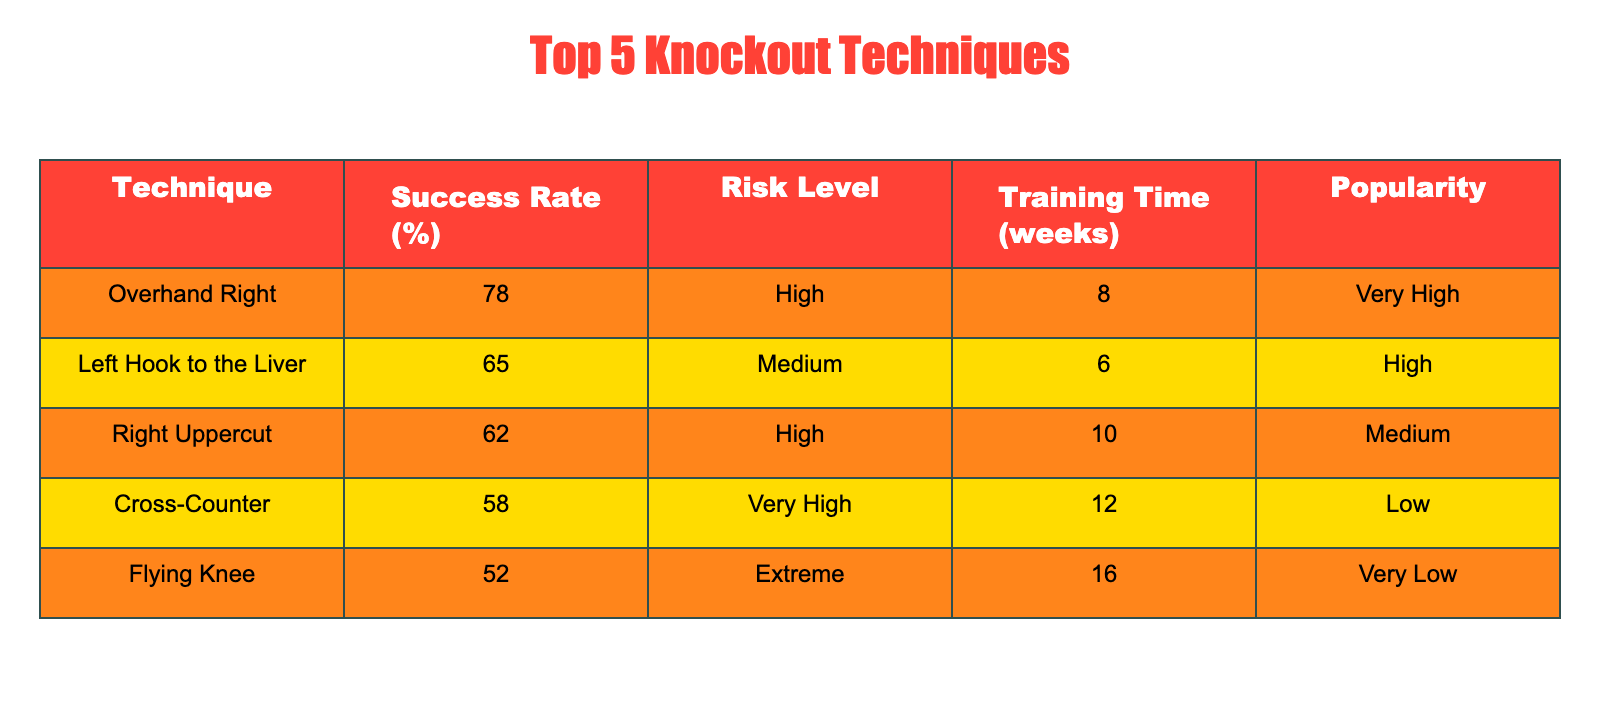What is the success rate of the Overhand Right technique? The table clearly lists the success rate of the Overhand Right technique, which is 78%.
Answer: 78% Which technique has the highest risk level and what is its success rate? The technique with the highest risk level is the Overhand Right, and its success rate is 78%.
Answer: Overhand Right, 78% How many weeks of training are required for the Cross-Counter? The table indicates that the Cross-Counter technique requires 12 weeks of training, which can be directly retrieved.
Answer: 12 weeks What is the average success rate of the top 5 knockout techniques? To find the average, sum the success rates: (78 + 65 + 62 + 58 + 52) = 315. There are 5 techniques, so the average success rate is 315 / 5 = 63%.
Answer: 63% Is the Flying Knee technique more popular than the Left Hook to the Liver? The table states that the Flyin Knee has "Very Low" popularity and the Left Hook to the Liver has "High" popularity, which indicates that the Left Hook to the Liver is indeed more popular.
Answer: No Which knockout technique requires the least amount of training time and what is that time? The technique with the least amount of training time is the Left Hook to the Liver, requiring 6 weeks as seen in the table.
Answer: 6 weeks Which techniques have a success rate above 60%? Looking at the success rates, the Overhand Right (78%), Left Hook to the Liver (65%), and Right Uppercut (62%) are above 60%.
Answer: Overhand Right, Left Hook to the Liver, Right Uppercut What is the difference in success rates between the Right Uppercut and the Flying Knee? The success rate of the Right Uppercut is 62% and for the Flying Knee it is 52%. Therefore, the difference is 62 - 52 = 10%.
Answer: 10% Is there any technique with an "Extreme" risk level? The Flying Knee has an "Extreme" risk level according to the data presented in the table.
Answer: No 